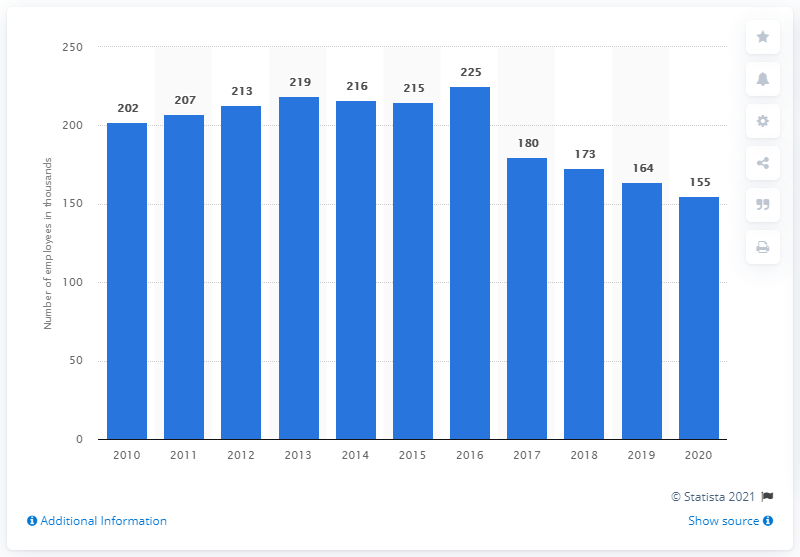Draw attention to some important aspects in this diagram. General Motors continued to restructure in 2020. 